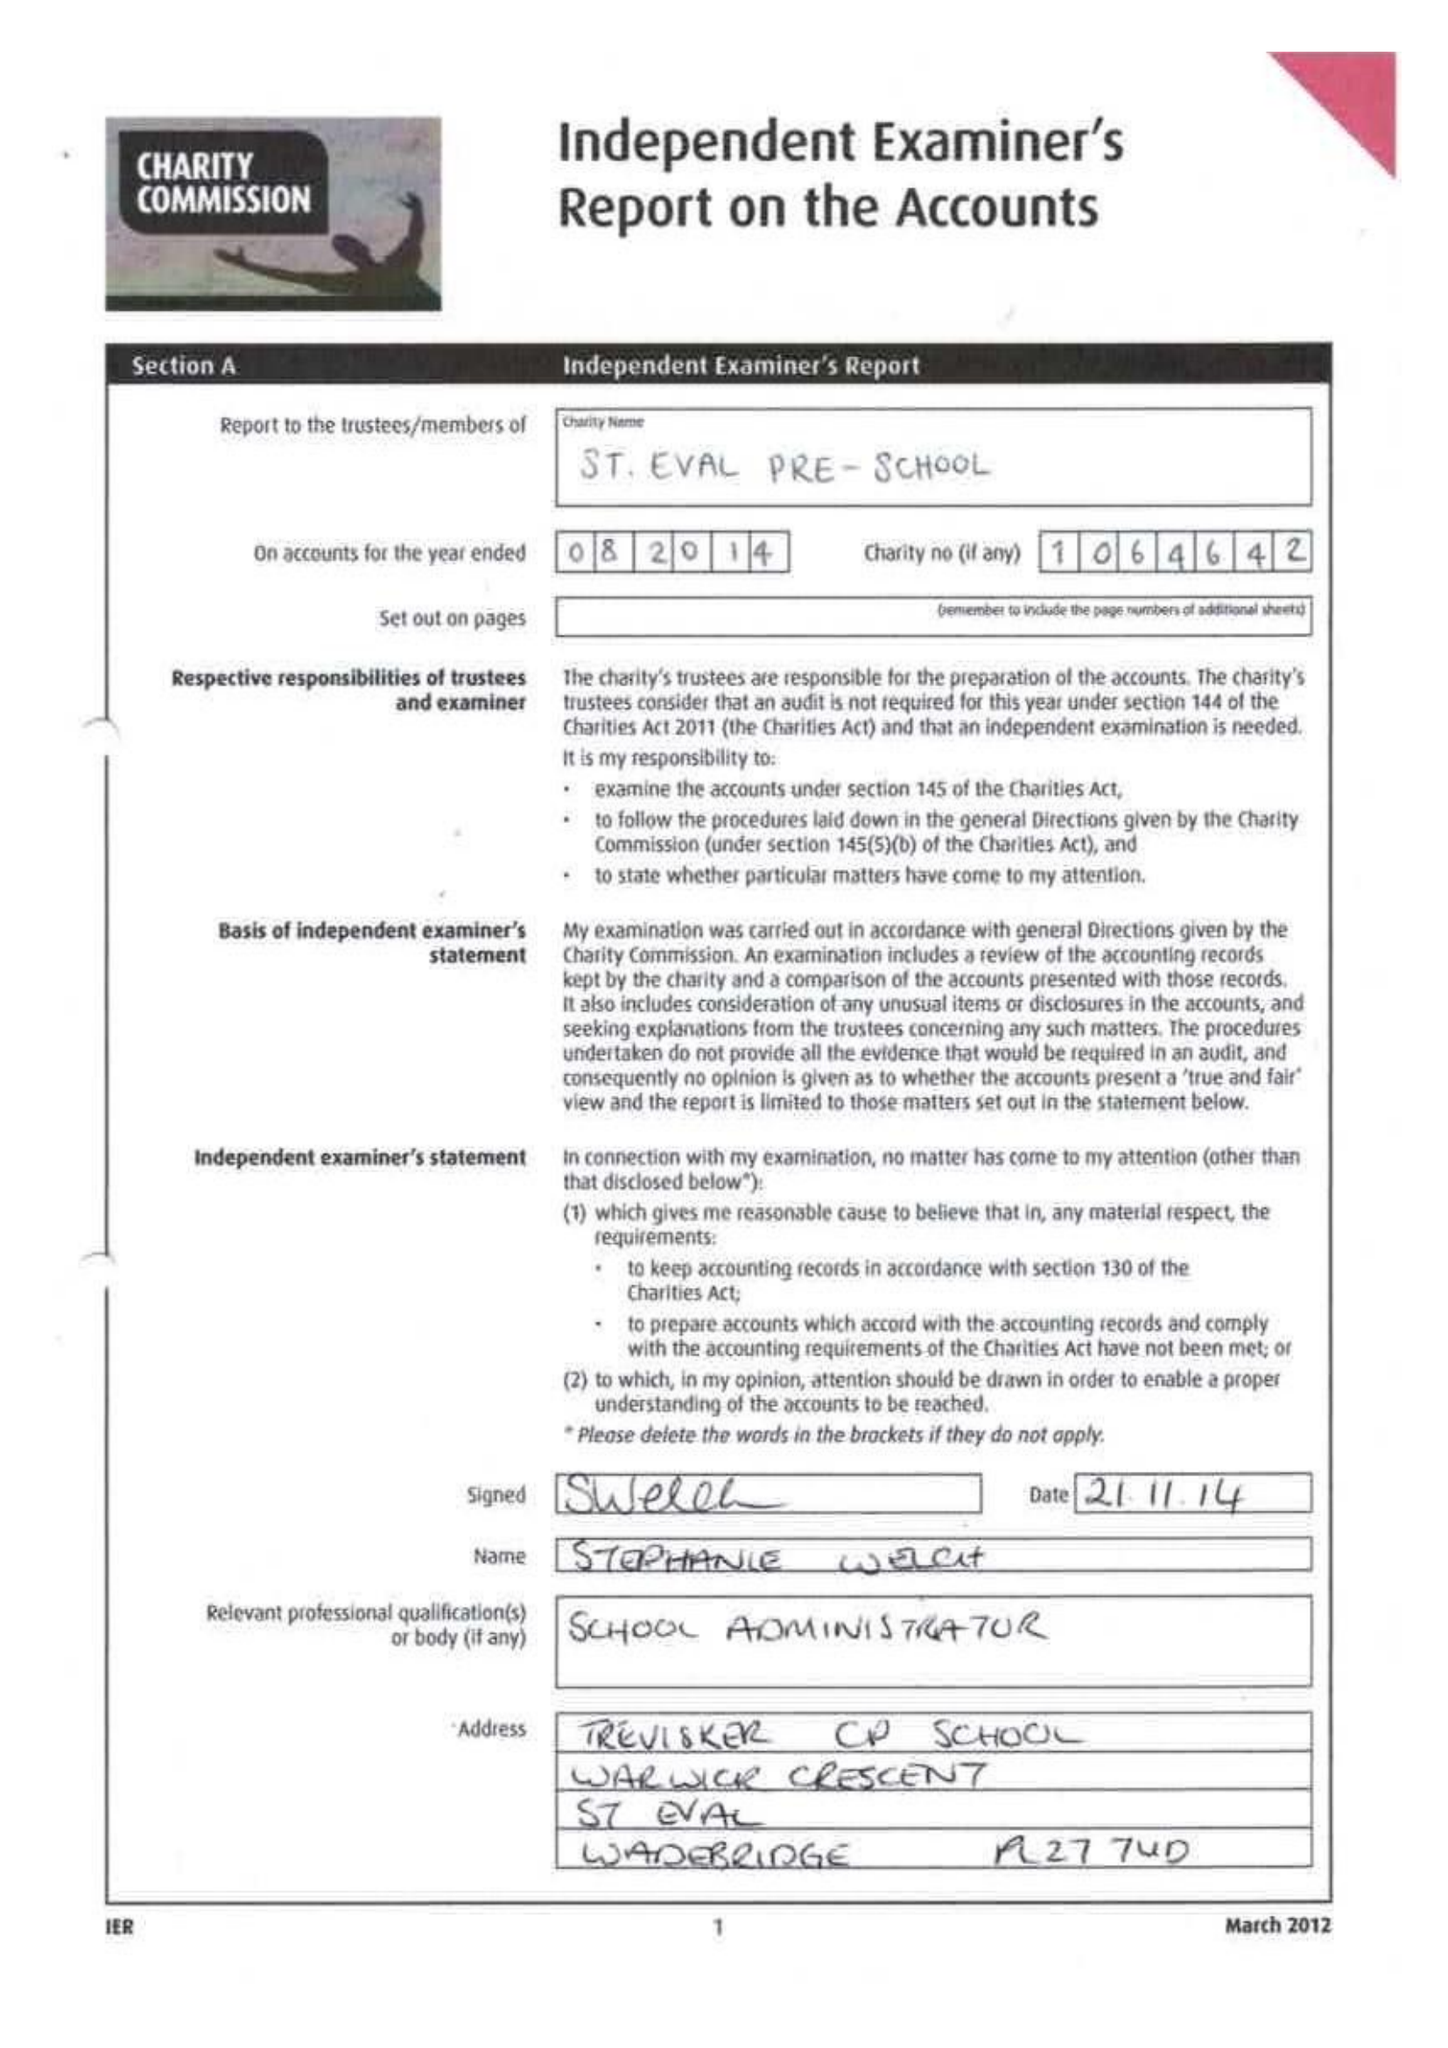What is the value for the address__street_line?
Answer the question using a single word or phrase. LINCOLN ROW 